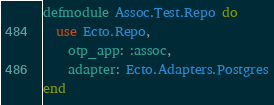<code> <loc_0><loc_0><loc_500><loc_500><_Elixir_>defmodule Assoc.Test.Repo do
  use Ecto.Repo,
    otp_app: :assoc,
    adapter: Ecto.Adapters.Postgres
end
</code> 